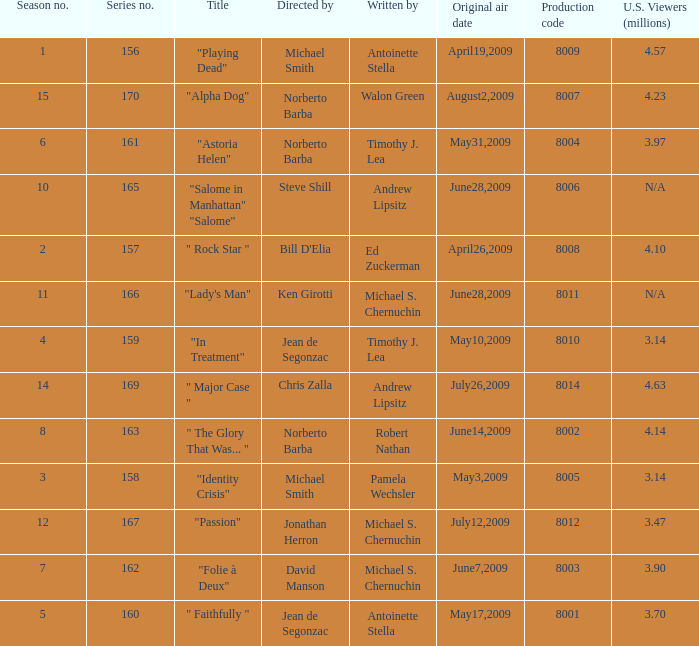What is the name of the episode whose writer is timothy j. lea and the director is norberto barba? "Astoria Helen". 